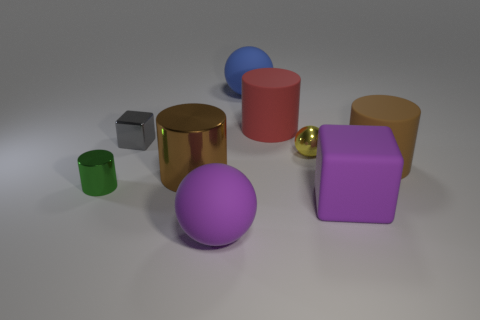Can you tell me the different colors of the objects present in the image? Certainly! In the image, there is a green cylinder, a gold cube, a red cylinder, a blue hemisphere, a purple cube, and a smaller gold sphere. 